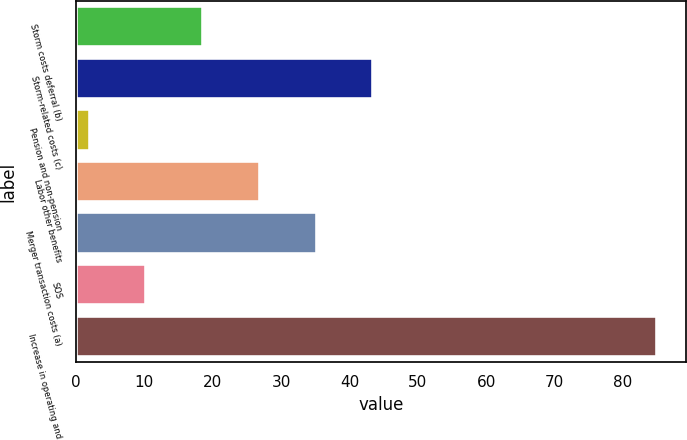Convert chart. <chart><loc_0><loc_0><loc_500><loc_500><bar_chart><fcel>Storm costs deferral (b)<fcel>Storm-related costs (c)<fcel>Pension and non-pension<fcel>Labor other benefits<fcel>Merger transaction costs (a)<fcel>SOS<fcel>Increase in operating and<nl><fcel>18.6<fcel>43.5<fcel>2<fcel>26.9<fcel>35.2<fcel>10.3<fcel>85<nl></chart> 